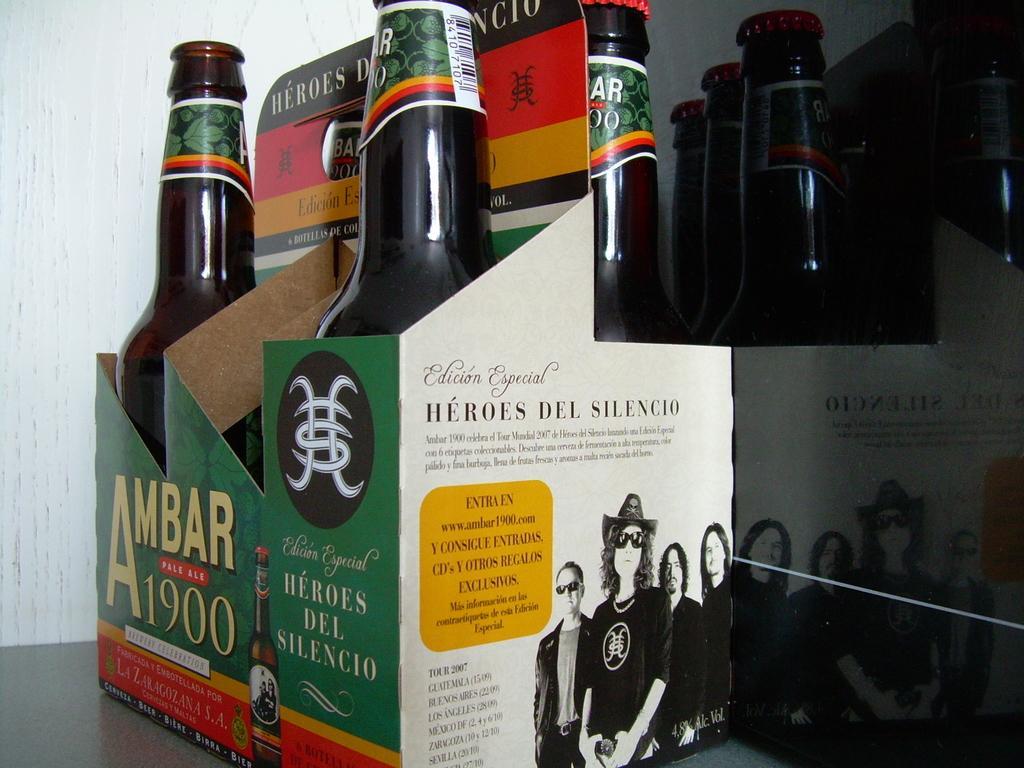Could you give a brief overview of what you see in this image? In the center of the image there are bottles arranged in a box. In the background of the image there is a wall. 